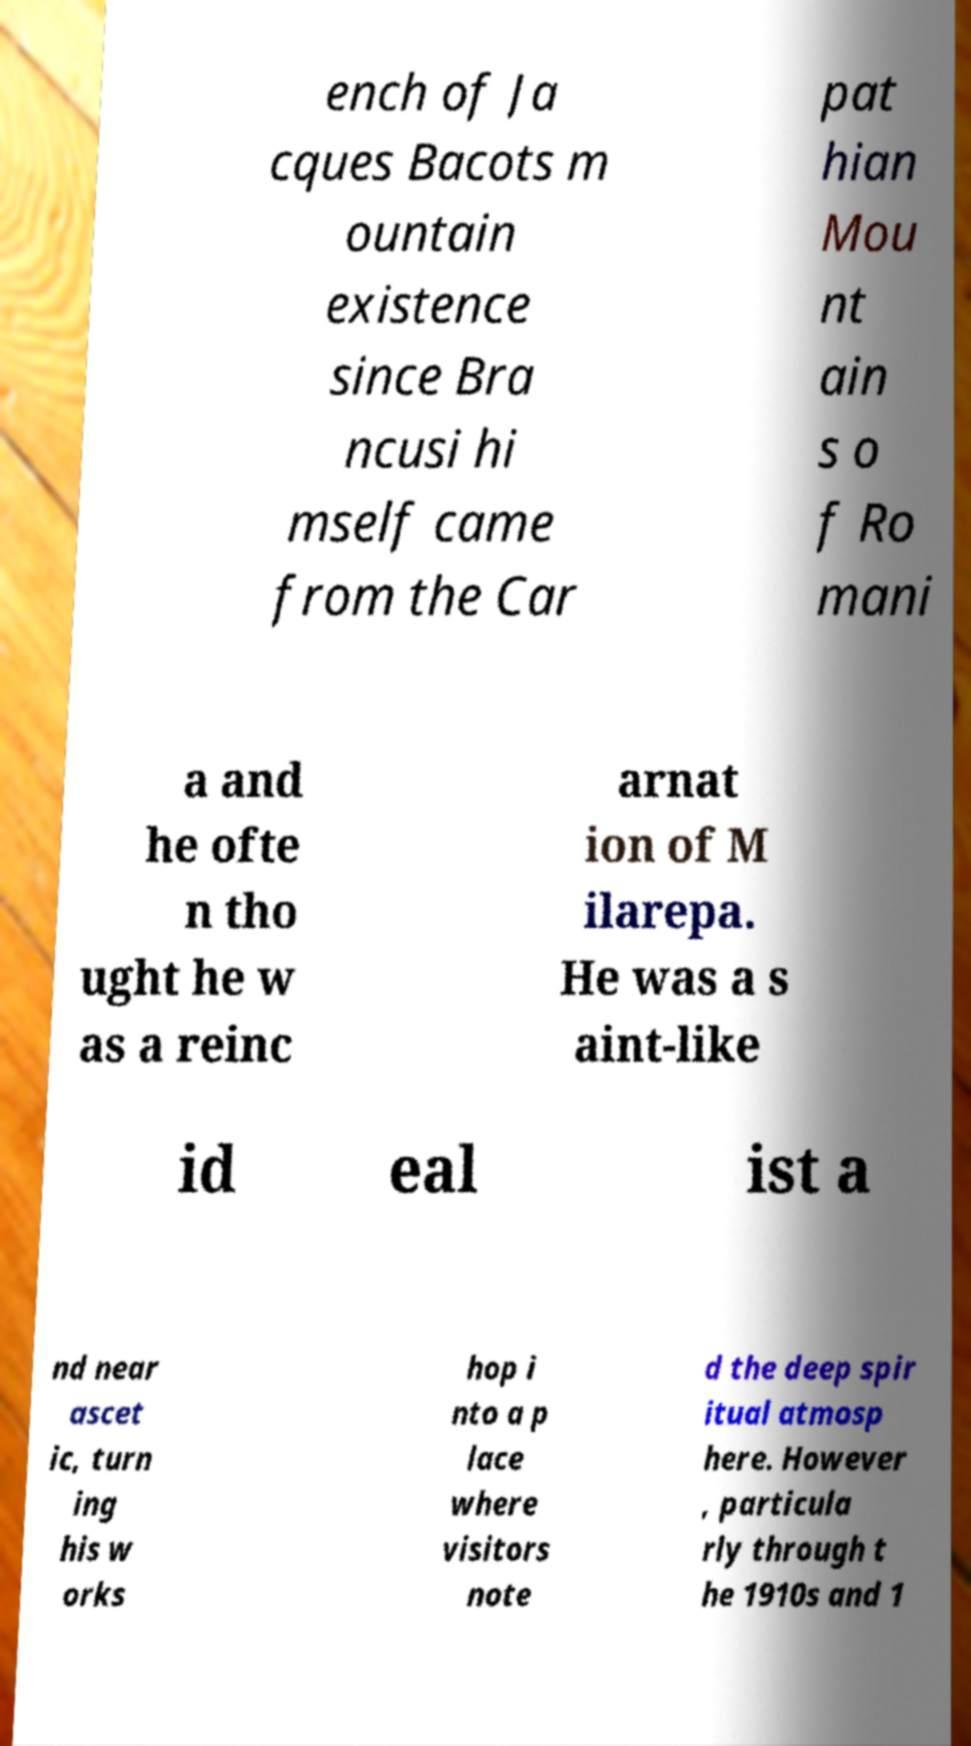Could you assist in decoding the text presented in this image and type it out clearly? ench of Ja cques Bacots m ountain existence since Bra ncusi hi mself came from the Car pat hian Mou nt ain s o f Ro mani a and he ofte n tho ught he w as a reinc arnat ion of M ilarepa. He was a s aint-like id eal ist a nd near ascet ic, turn ing his w orks hop i nto a p lace where visitors note d the deep spir itual atmosp here. However , particula rly through t he 1910s and 1 